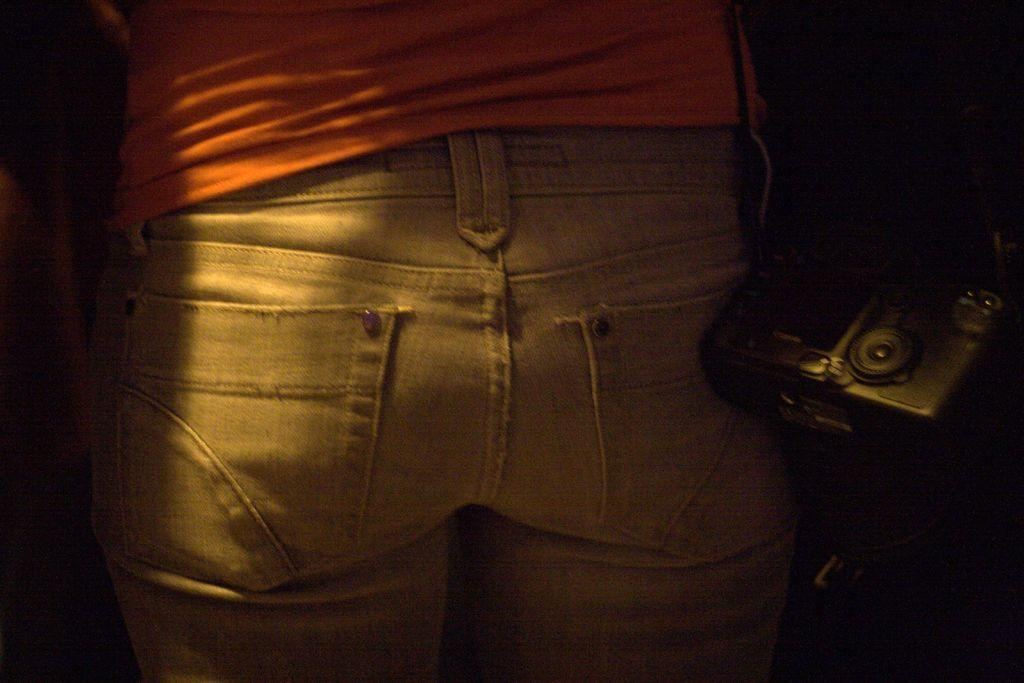What is the main subject of the image? There is a person standing in the image. What is the person wearing on their upper body? The person is wearing an orange t-shirt. What type of clothing is the person wearing on their lower body? The person is wearing a pant. Can you describe any objects or devices visible in the image? There is a camera to the right of the image. What is the title of the book the person is holding in the image? There is no book visible in the image. 